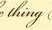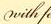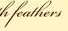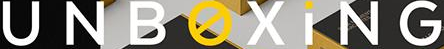What words can you see in these images in sequence, separated by a semicolon? thing; with; feathers; UNBOXiNG 